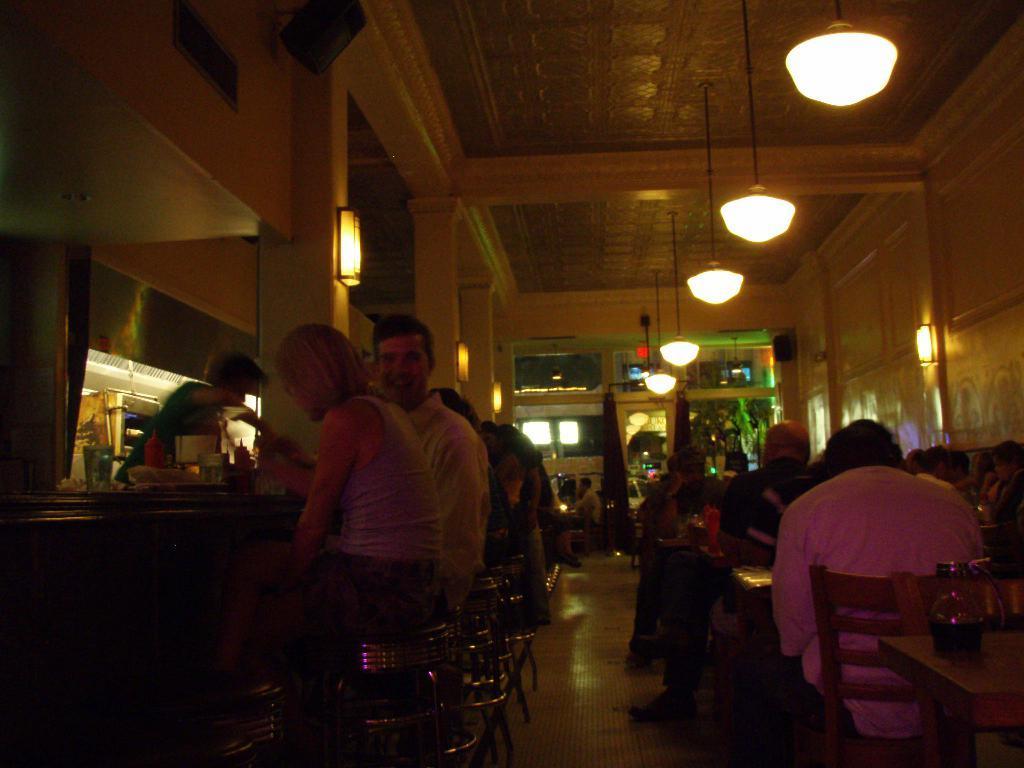Please provide a concise description of this image. In this image we can see some group of persons who are sitting on the chairs around table having some food and drinks at the left side of the image there is person standing behind the counter and supplying drinks and at the background of the image there are some lights and door. 